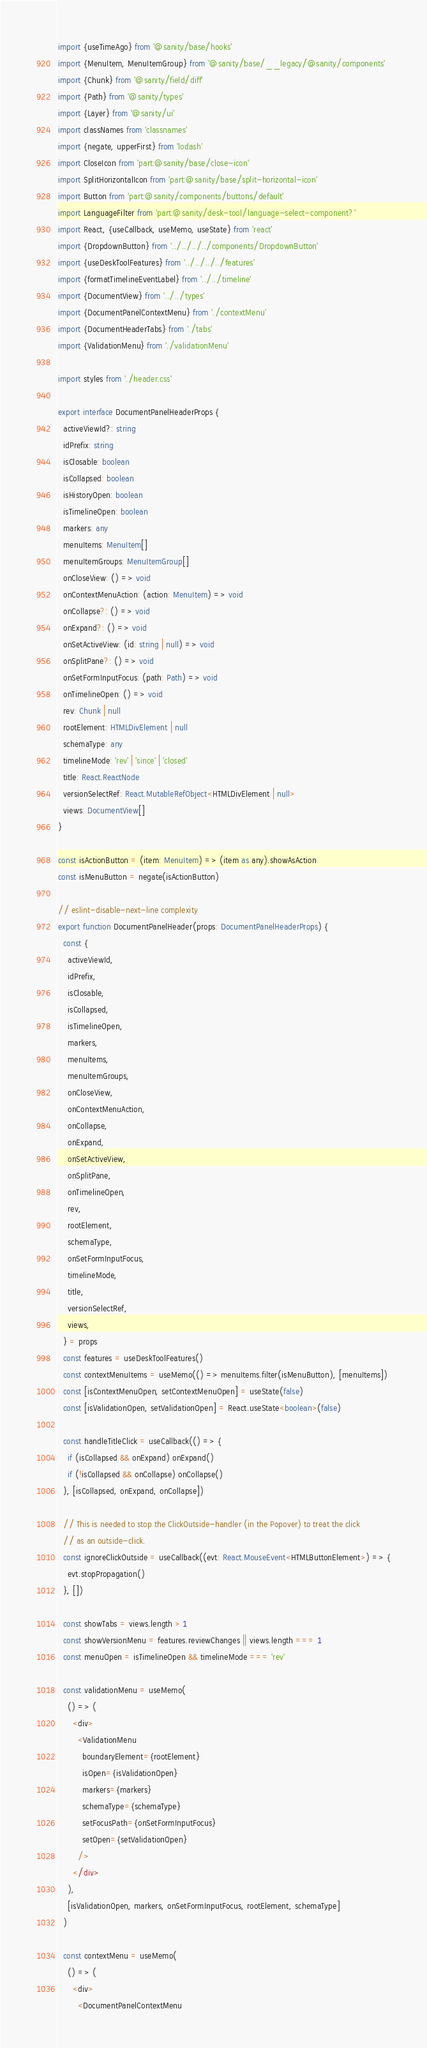<code> <loc_0><loc_0><loc_500><loc_500><_TypeScript_>import {useTimeAgo} from '@sanity/base/hooks'
import {MenuItem, MenuItemGroup} from '@sanity/base/__legacy/@sanity/components'
import {Chunk} from '@sanity/field/diff'
import {Path} from '@sanity/types'
import {Layer} from '@sanity/ui'
import classNames from 'classnames'
import {negate, upperFirst} from 'lodash'
import CloseIcon from 'part:@sanity/base/close-icon'
import SplitHorizontalIcon from 'part:@sanity/base/split-horizontal-icon'
import Button from 'part:@sanity/components/buttons/default'
import LanguageFilter from 'part:@sanity/desk-tool/language-select-component?'
import React, {useCallback, useMemo, useState} from 'react'
import {DropdownButton} from '../../../../components/DropdownButton'
import {useDeskToolFeatures} from '../../../../features'
import {formatTimelineEventLabel} from '../../timeline'
import {DocumentView} from '../../types'
import {DocumentPanelContextMenu} from './contextMenu'
import {DocumentHeaderTabs} from './tabs'
import {ValidationMenu} from './validationMenu'

import styles from './header.css'

export interface DocumentPanelHeaderProps {
  activeViewId?: string
  idPrefix: string
  isClosable: boolean
  isCollapsed: boolean
  isHistoryOpen: boolean
  isTimelineOpen: boolean
  markers: any
  menuItems: MenuItem[]
  menuItemGroups: MenuItemGroup[]
  onCloseView: () => void
  onContextMenuAction: (action: MenuItem) => void
  onCollapse?: () => void
  onExpand?: () => void
  onSetActiveView: (id: string | null) => void
  onSplitPane?: () => void
  onSetFormInputFocus: (path: Path) => void
  onTimelineOpen: () => void
  rev: Chunk | null
  rootElement: HTMLDivElement | null
  schemaType: any
  timelineMode: 'rev' | 'since' | 'closed'
  title: React.ReactNode
  versionSelectRef: React.MutableRefObject<HTMLDivElement | null>
  views: DocumentView[]
}

const isActionButton = (item: MenuItem) => (item as any).showAsAction
const isMenuButton = negate(isActionButton)

// eslint-disable-next-line complexity
export function DocumentPanelHeader(props: DocumentPanelHeaderProps) {
  const {
    activeViewId,
    idPrefix,
    isClosable,
    isCollapsed,
    isTimelineOpen,
    markers,
    menuItems,
    menuItemGroups,
    onCloseView,
    onContextMenuAction,
    onCollapse,
    onExpand,
    onSetActiveView,
    onSplitPane,
    onTimelineOpen,
    rev,
    rootElement,
    schemaType,
    onSetFormInputFocus,
    timelineMode,
    title,
    versionSelectRef,
    views,
  } = props
  const features = useDeskToolFeatures()
  const contextMenuItems = useMemo(() => menuItems.filter(isMenuButton), [menuItems])
  const [isContextMenuOpen, setContextMenuOpen] = useState(false)
  const [isValidationOpen, setValidationOpen] = React.useState<boolean>(false)

  const handleTitleClick = useCallback(() => {
    if (isCollapsed && onExpand) onExpand()
    if (!isCollapsed && onCollapse) onCollapse()
  }, [isCollapsed, onExpand, onCollapse])

  // This is needed to stop the ClickOutside-handler (in the Popover) to treat the click
  // as an outside-click.
  const ignoreClickOutside = useCallback((evt: React.MouseEvent<HTMLButtonElement>) => {
    evt.stopPropagation()
  }, [])

  const showTabs = views.length > 1
  const showVersionMenu = features.reviewChanges || views.length === 1
  const menuOpen = isTimelineOpen && timelineMode === 'rev'

  const validationMenu = useMemo(
    () => (
      <div>
        <ValidationMenu
          boundaryElement={rootElement}
          isOpen={isValidationOpen}
          markers={markers}
          schemaType={schemaType}
          setFocusPath={onSetFormInputFocus}
          setOpen={setValidationOpen}
        />
      </div>
    ),
    [isValidationOpen, markers, onSetFormInputFocus, rootElement, schemaType]
  )

  const contextMenu = useMemo(
    () => (
      <div>
        <DocumentPanelContextMenu</code> 